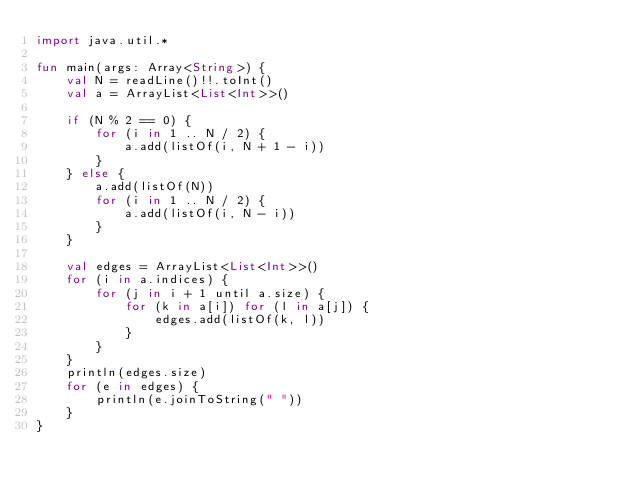<code> <loc_0><loc_0><loc_500><loc_500><_Kotlin_>import java.util.*

fun main(args: Array<String>) {
    val N = readLine()!!.toInt()
    val a = ArrayList<List<Int>>()

    if (N % 2 == 0) {
        for (i in 1 .. N / 2) {
            a.add(listOf(i, N + 1 - i))
        }
    } else {
        a.add(listOf(N))
        for (i in 1 .. N / 2) {
            a.add(listOf(i, N - i))
        }
    }

    val edges = ArrayList<List<Int>>()
    for (i in a.indices) {
        for (j in i + 1 until a.size) {
            for (k in a[i]) for (l in a[j]) {
                edges.add(listOf(k, l))
            }
        }
    }
    println(edges.size)
    for (e in edges) {
        println(e.joinToString(" "))
    }
}
</code> 